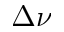<formula> <loc_0><loc_0><loc_500><loc_500>\Delta \nu</formula> 